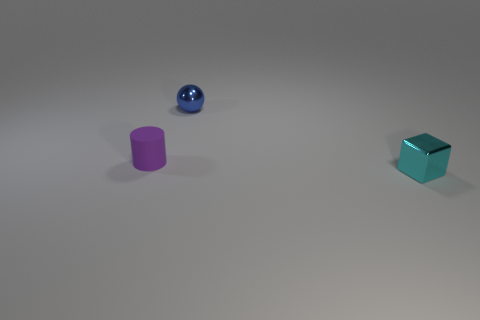This image has a minimalist setup with only three objects present. Could you give me an idea of what concept this might be trying to convey? The image's minimalist nature, featuring only three objects with different geometric shapes, suggests a focus on simplicity and form. It might convey the concept of diversity within simplicity - showing how varied shapes and materials can coexist harmoniously within a sparse environment. The image may also be exploring the theme of spatial relationships, with each object's positioning creating balance within the composition. 